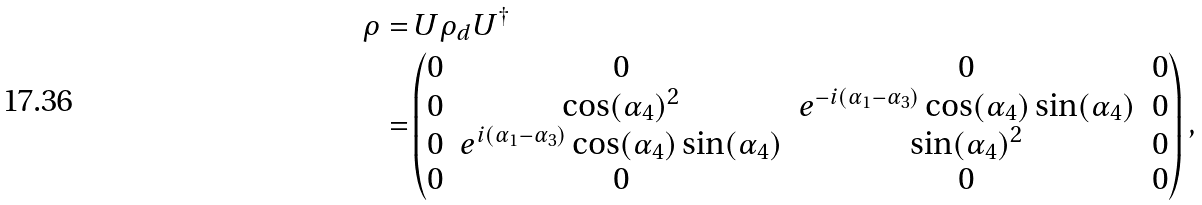Convert formula to latex. <formula><loc_0><loc_0><loc_500><loc_500>\rho = & \, U \rho _ { d } U ^ { \dagger } \\ = & \begin{pmatrix} 0 & 0 & 0 & 0 \\ 0 & \cos ( \alpha _ { 4 } ) ^ { 2 } & e ^ { - i ( \alpha _ { 1 } - \alpha _ { 3 } ) } \cos ( \alpha _ { 4 } ) \sin ( \alpha _ { 4 } ) & 0 \\ 0 & e ^ { i ( \alpha _ { 1 } - \alpha _ { 3 } ) } \cos ( \alpha _ { 4 } ) \sin ( \alpha _ { 4 } ) & \sin ( \alpha _ { 4 } ) ^ { 2 } & 0 \\ 0 & 0 & 0 & 0 \end{pmatrix} ,</formula> 